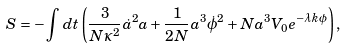Convert formula to latex. <formula><loc_0><loc_0><loc_500><loc_500>S = - \int d t \left ( \frac { 3 } { N \kappa ^ { 2 } } \dot { a } ^ { 2 } a + \frac { 1 } { 2 N } a ^ { 3 } \dot { \phi } ^ { 2 } + N a ^ { 3 } V _ { 0 } e ^ { - \lambda k \phi } \right ) ,</formula> 